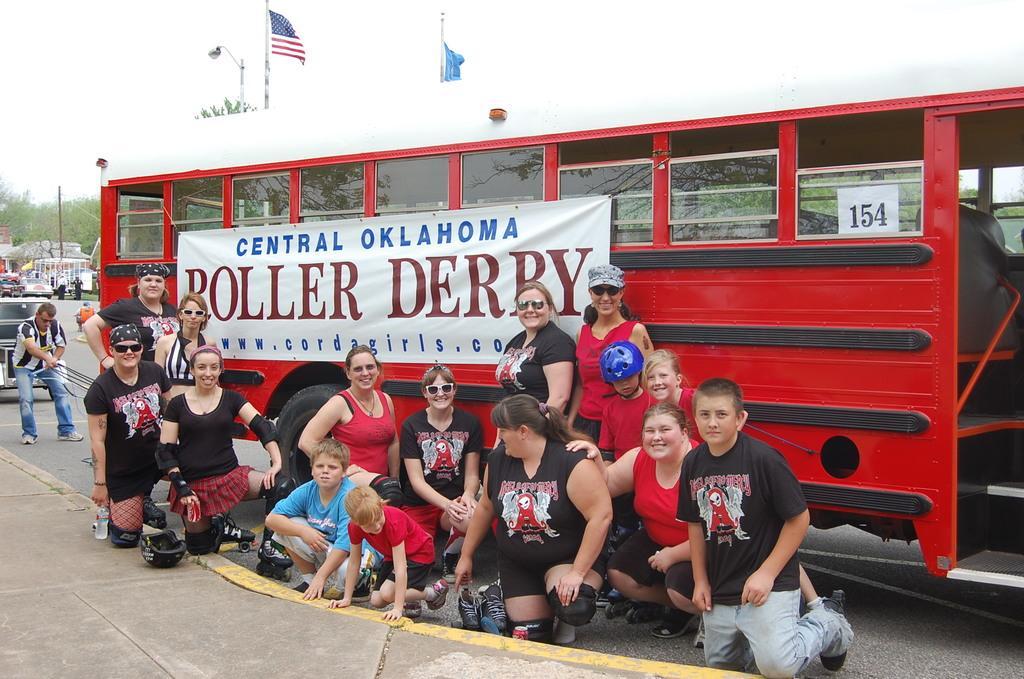How would you summarize this image in a sentence or two? In this image I can see few people around. I can see few vehicles and in front I can see red and black color vehicle and banner is attached to it. I can see trees,light-pole,flags. The sky is in white color. 